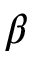<formula> <loc_0><loc_0><loc_500><loc_500>\beta</formula> 